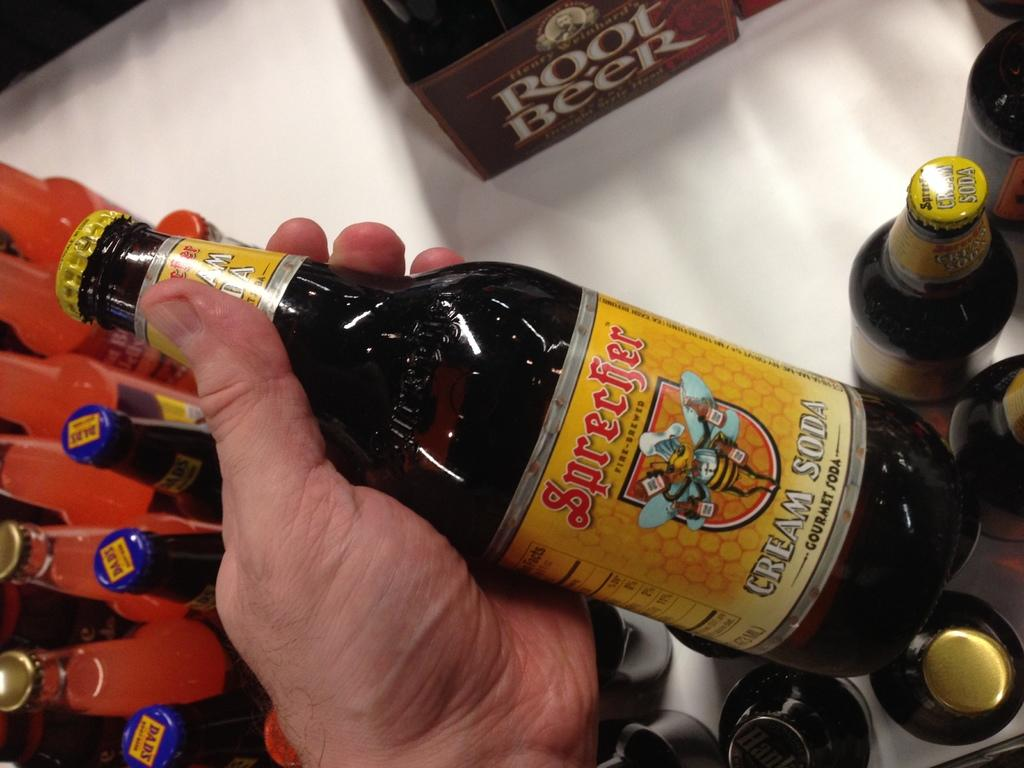<image>
Offer a succinct explanation of the picture presented. A bottle of cream soda that is gourmet by the name of Sprecher. 